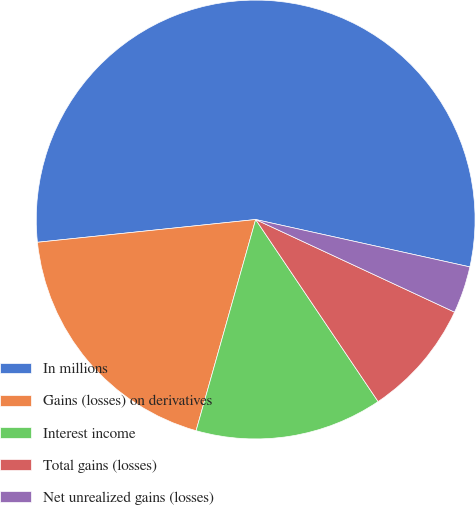<chart> <loc_0><loc_0><loc_500><loc_500><pie_chart><fcel>In millions<fcel>Gains (losses) on derivatives<fcel>Interest income<fcel>Total gains (losses)<fcel>Net unrealized gains (losses)<nl><fcel>55.12%<fcel>18.97%<fcel>13.8%<fcel>8.64%<fcel>3.47%<nl></chart> 